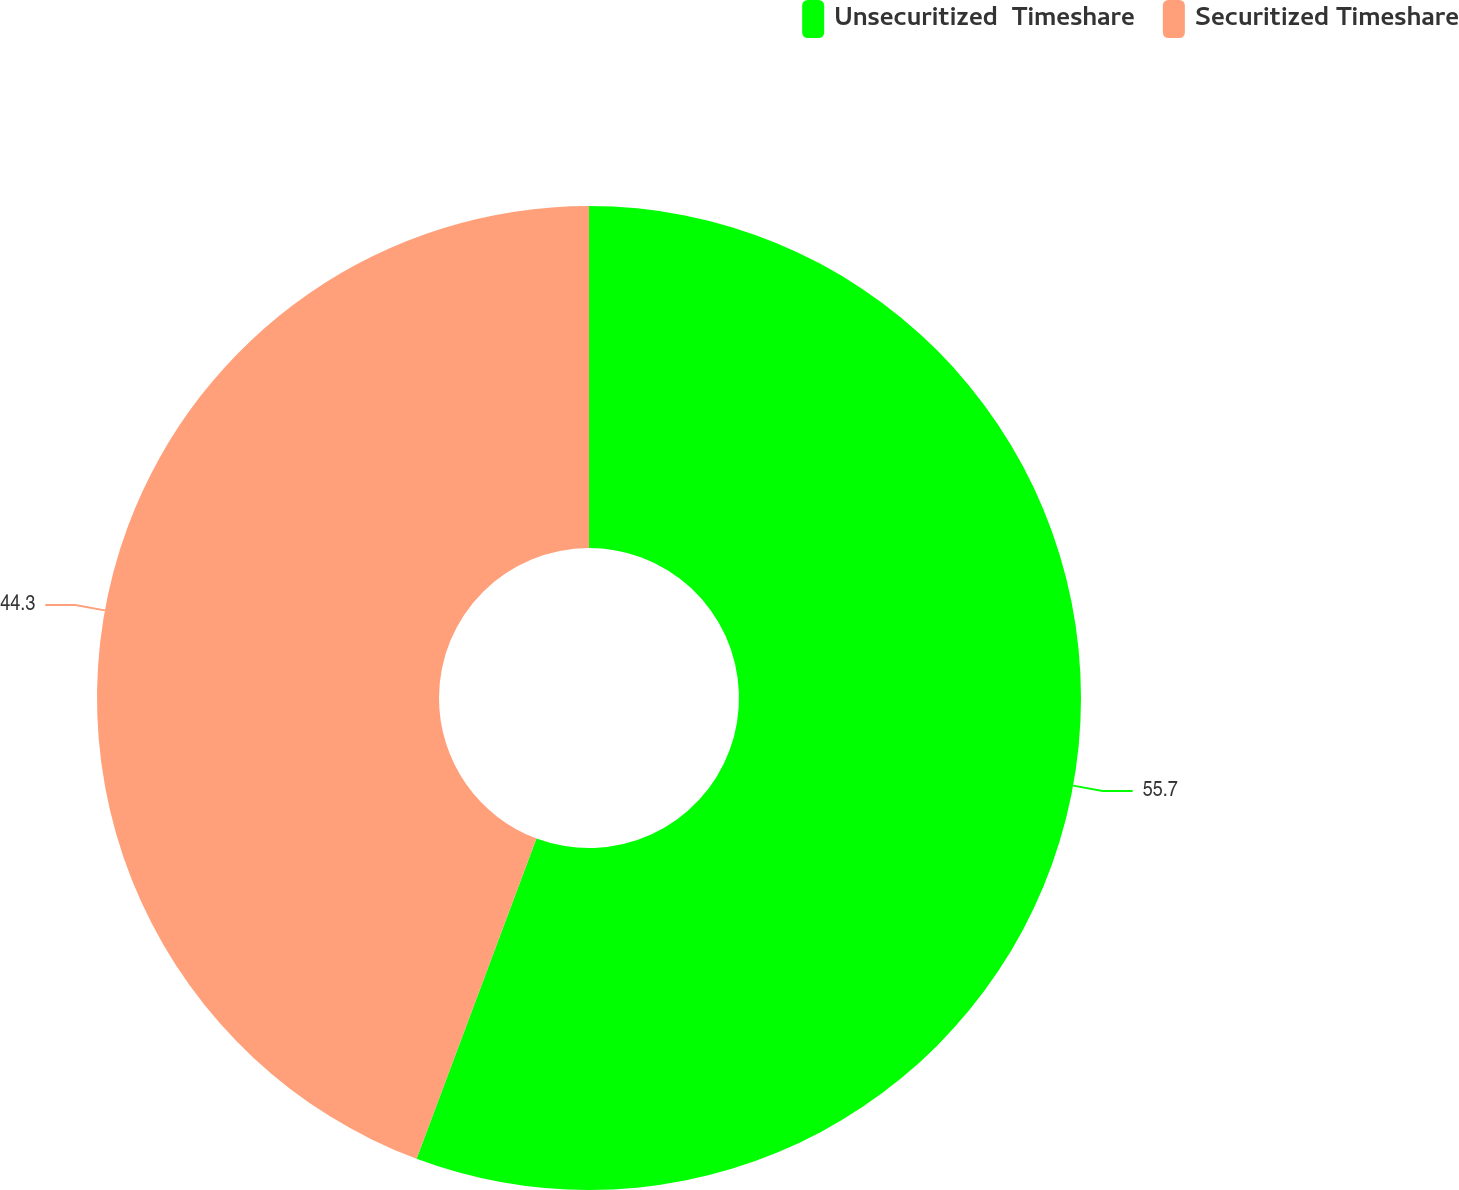Convert chart. <chart><loc_0><loc_0><loc_500><loc_500><pie_chart><fcel>Unsecuritized  Timeshare<fcel>Securitized Timeshare<nl><fcel>55.7%<fcel>44.3%<nl></chart> 